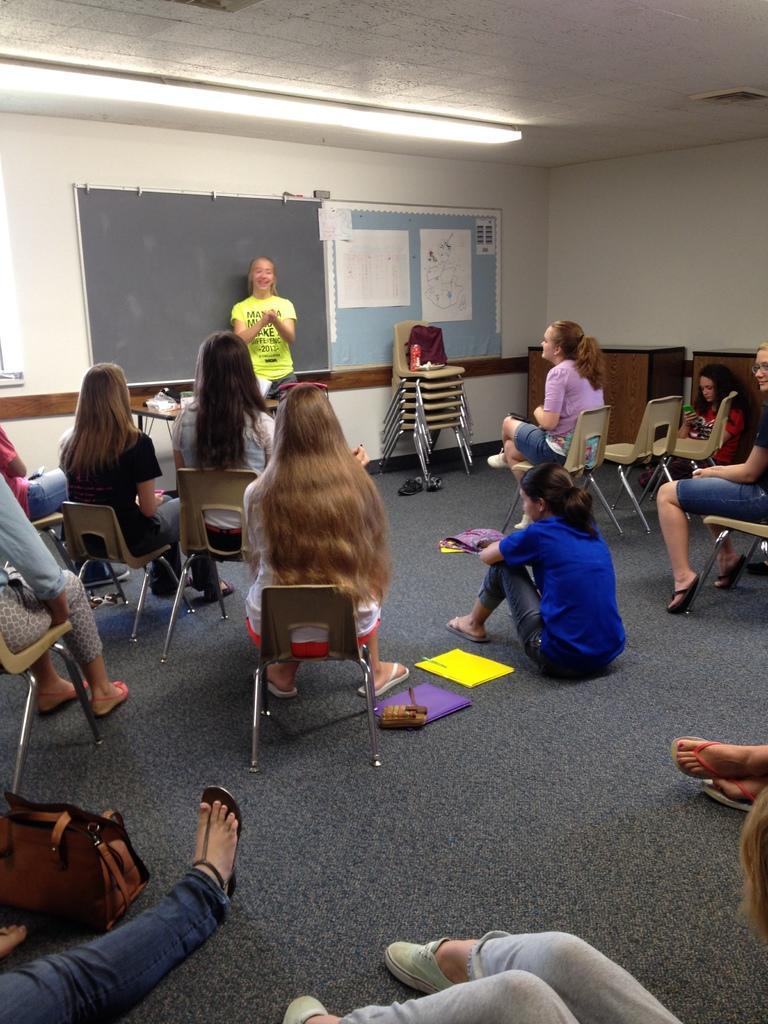How would you summarize this image in a sentence or two? In this image I can see number of people are sitting on chairs. Here I can see a girl is standing near blackboard. 